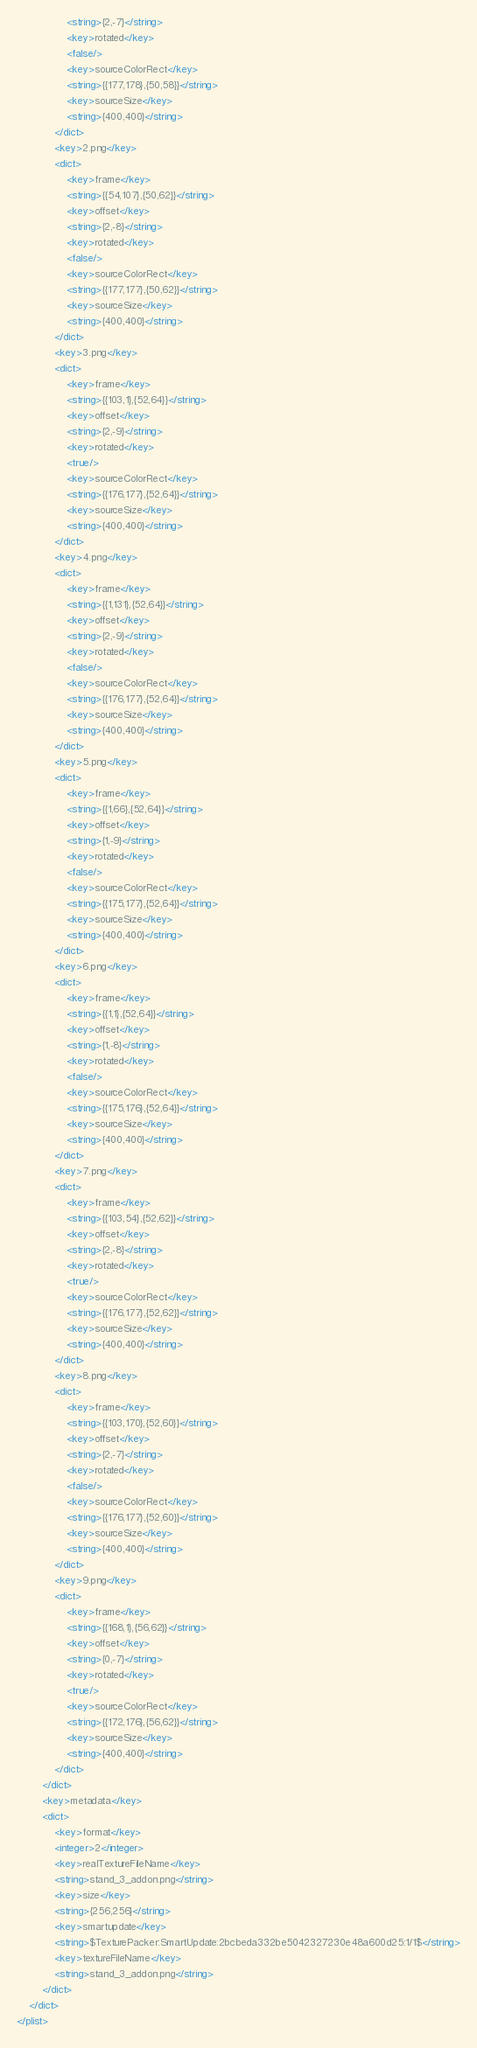Convert code to text. <code><loc_0><loc_0><loc_500><loc_500><_XML_>                <string>{2,-7}</string>
                <key>rotated</key>
                <false/>
                <key>sourceColorRect</key>
                <string>{{177,178},{50,58}}</string>
                <key>sourceSize</key>
                <string>{400,400}</string>
            </dict>
            <key>2.png</key>
            <dict>
                <key>frame</key>
                <string>{{54,107},{50,62}}</string>
                <key>offset</key>
                <string>{2,-8}</string>
                <key>rotated</key>
                <false/>
                <key>sourceColorRect</key>
                <string>{{177,177},{50,62}}</string>
                <key>sourceSize</key>
                <string>{400,400}</string>
            </dict>
            <key>3.png</key>
            <dict>
                <key>frame</key>
                <string>{{103,1},{52,64}}</string>
                <key>offset</key>
                <string>{2,-9}</string>
                <key>rotated</key>
                <true/>
                <key>sourceColorRect</key>
                <string>{{176,177},{52,64}}</string>
                <key>sourceSize</key>
                <string>{400,400}</string>
            </dict>
            <key>4.png</key>
            <dict>
                <key>frame</key>
                <string>{{1,131},{52,64}}</string>
                <key>offset</key>
                <string>{2,-9}</string>
                <key>rotated</key>
                <false/>
                <key>sourceColorRect</key>
                <string>{{176,177},{52,64}}</string>
                <key>sourceSize</key>
                <string>{400,400}</string>
            </dict>
            <key>5.png</key>
            <dict>
                <key>frame</key>
                <string>{{1,66},{52,64}}</string>
                <key>offset</key>
                <string>{1,-9}</string>
                <key>rotated</key>
                <false/>
                <key>sourceColorRect</key>
                <string>{{175,177},{52,64}}</string>
                <key>sourceSize</key>
                <string>{400,400}</string>
            </dict>
            <key>6.png</key>
            <dict>
                <key>frame</key>
                <string>{{1,1},{52,64}}</string>
                <key>offset</key>
                <string>{1,-8}</string>
                <key>rotated</key>
                <false/>
                <key>sourceColorRect</key>
                <string>{{175,176},{52,64}}</string>
                <key>sourceSize</key>
                <string>{400,400}</string>
            </dict>
            <key>7.png</key>
            <dict>
                <key>frame</key>
                <string>{{103,54},{52,62}}</string>
                <key>offset</key>
                <string>{2,-8}</string>
                <key>rotated</key>
                <true/>
                <key>sourceColorRect</key>
                <string>{{176,177},{52,62}}</string>
                <key>sourceSize</key>
                <string>{400,400}</string>
            </dict>
            <key>8.png</key>
            <dict>
                <key>frame</key>
                <string>{{103,170},{52,60}}</string>
                <key>offset</key>
                <string>{2,-7}</string>
                <key>rotated</key>
                <false/>
                <key>sourceColorRect</key>
                <string>{{176,177},{52,60}}</string>
                <key>sourceSize</key>
                <string>{400,400}</string>
            </dict>
            <key>9.png</key>
            <dict>
                <key>frame</key>
                <string>{{168,1},{56,62}}</string>
                <key>offset</key>
                <string>{0,-7}</string>
                <key>rotated</key>
                <true/>
                <key>sourceColorRect</key>
                <string>{{172,176},{56,62}}</string>
                <key>sourceSize</key>
                <string>{400,400}</string>
            </dict>
        </dict>
        <key>metadata</key>
        <dict>
            <key>format</key>
            <integer>2</integer>
            <key>realTextureFileName</key>
            <string>stand_3_addon.png</string>
            <key>size</key>
            <string>{256,256}</string>
            <key>smartupdate</key>
            <string>$TexturePacker:SmartUpdate:2bcbeda332be5042327230e48a600d25:1/1$</string>
            <key>textureFileName</key>
            <string>stand_3_addon.png</string>
        </dict>
    </dict>
</plist>
</code> 